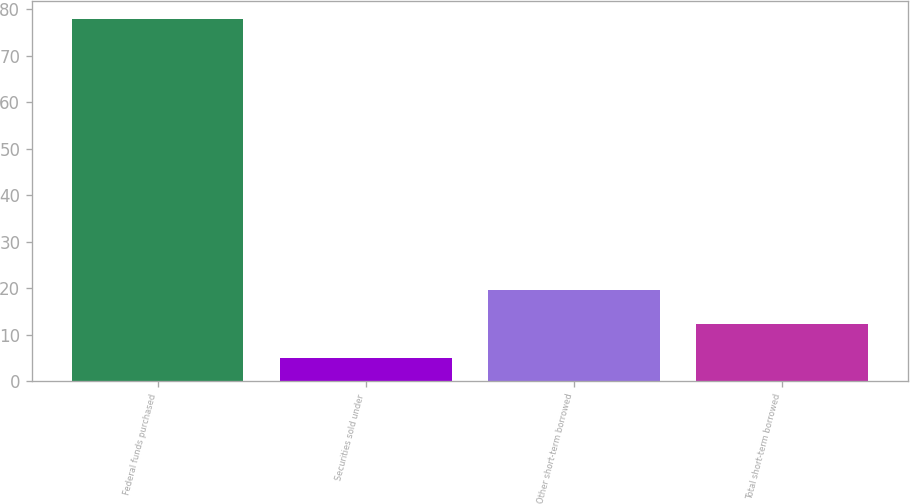Convert chart. <chart><loc_0><loc_0><loc_500><loc_500><bar_chart><fcel>Federal funds purchased<fcel>Securities sold under<fcel>Other short-term borrowed<fcel>Total short-term borrowed<nl><fcel>78<fcel>5<fcel>19.6<fcel>12.3<nl></chart> 